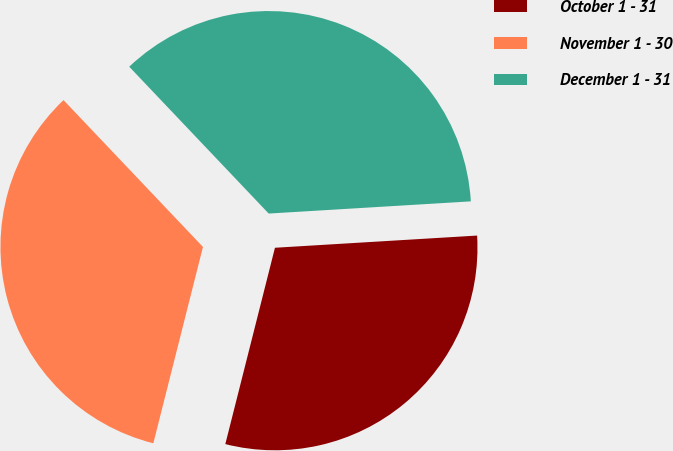Convert chart to OTSL. <chart><loc_0><loc_0><loc_500><loc_500><pie_chart><fcel>October 1 - 31<fcel>November 1 - 30<fcel>December 1 - 31<nl><fcel>29.9%<fcel>33.97%<fcel>36.13%<nl></chart> 